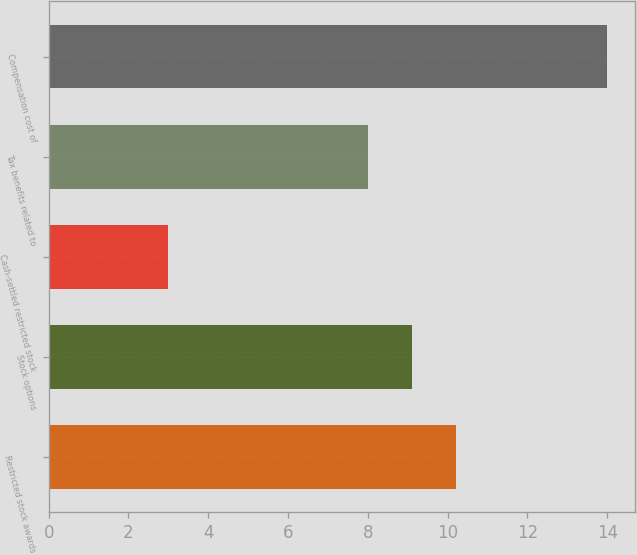Convert chart to OTSL. <chart><loc_0><loc_0><loc_500><loc_500><bar_chart><fcel>Restricted stock awards<fcel>Stock options<fcel>Cash-settled restricted stock<fcel>Tax benefits related to<fcel>Compensation cost of<nl><fcel>10.2<fcel>9.1<fcel>3<fcel>8<fcel>14<nl></chart> 